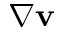<formula> <loc_0><loc_0><loc_500><loc_500>\nabla v</formula> 